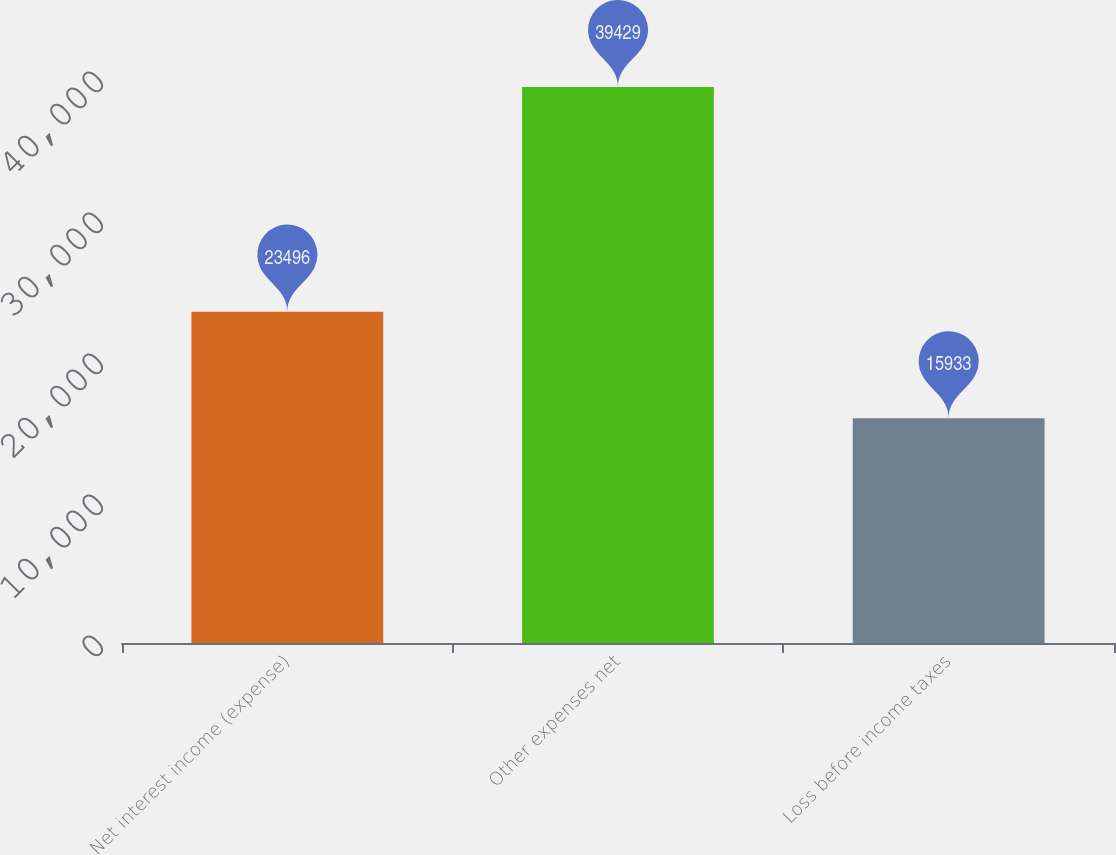Convert chart. <chart><loc_0><loc_0><loc_500><loc_500><bar_chart><fcel>Net interest income (expense)<fcel>Other expenses net<fcel>Loss before income taxes<nl><fcel>23496<fcel>39429<fcel>15933<nl></chart> 